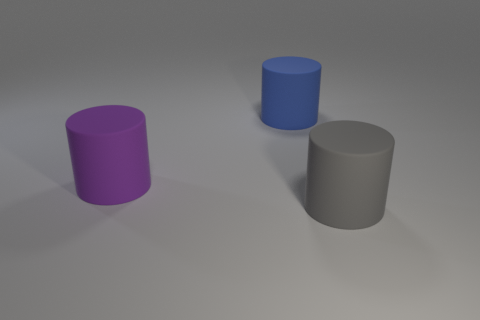Subtract all big purple matte cylinders. How many cylinders are left? 2 Add 1 large yellow cylinders. How many objects exist? 4 Subtract 1 cylinders. How many cylinders are left? 2 Add 3 gray things. How many gray things are left? 4 Add 2 small rubber spheres. How many small rubber spheres exist? 2 Subtract all blue cylinders. How many cylinders are left? 2 Subtract 0 red balls. How many objects are left? 3 Subtract all blue cylinders. Subtract all yellow spheres. How many cylinders are left? 2 Subtract all rubber things. Subtract all green matte blocks. How many objects are left? 0 